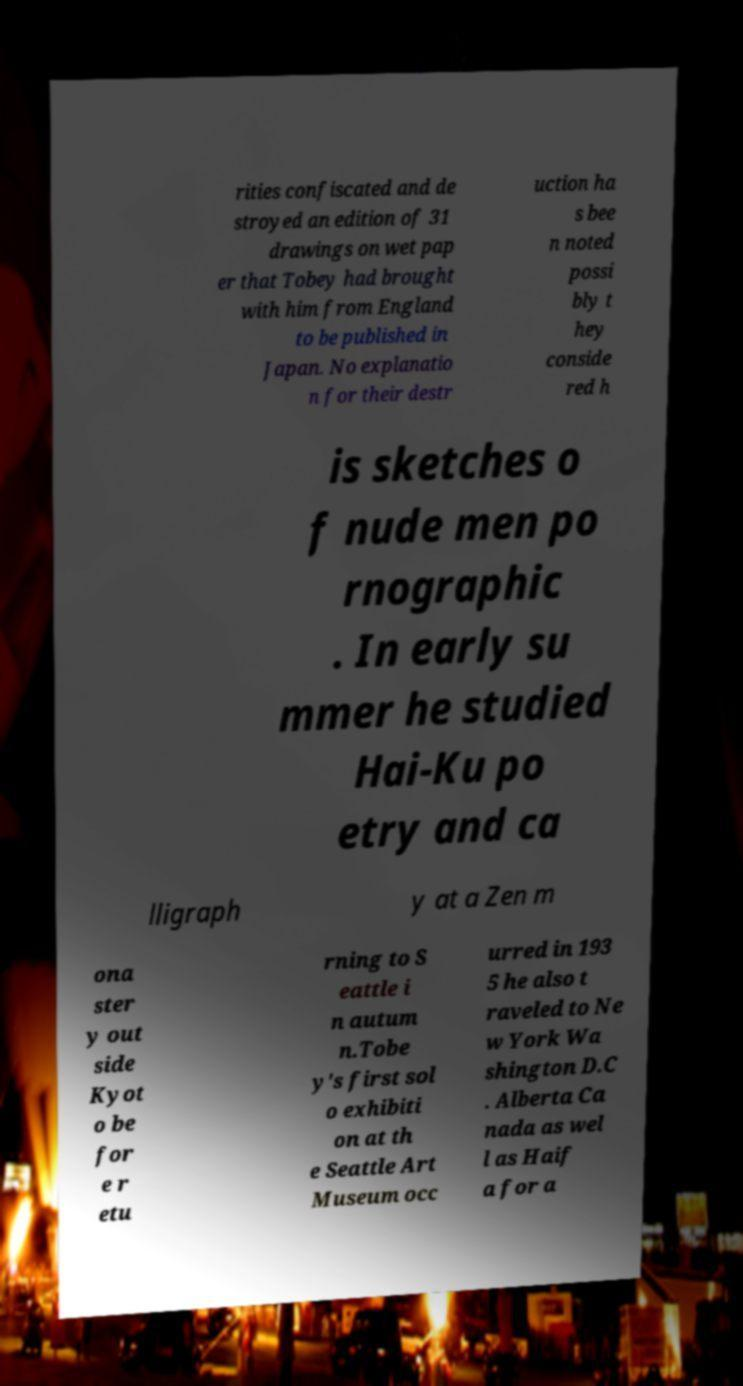Please read and relay the text visible in this image. What does it say? rities confiscated and de stroyed an edition of 31 drawings on wet pap er that Tobey had brought with him from England to be published in Japan. No explanatio n for their destr uction ha s bee n noted possi bly t hey conside red h is sketches o f nude men po rnographic . In early su mmer he studied Hai-Ku po etry and ca lligraph y at a Zen m ona ster y out side Kyot o be for e r etu rning to S eattle i n autum n.Tobe y's first sol o exhibiti on at th e Seattle Art Museum occ urred in 193 5 he also t raveled to Ne w York Wa shington D.C . Alberta Ca nada as wel l as Haif a for a 